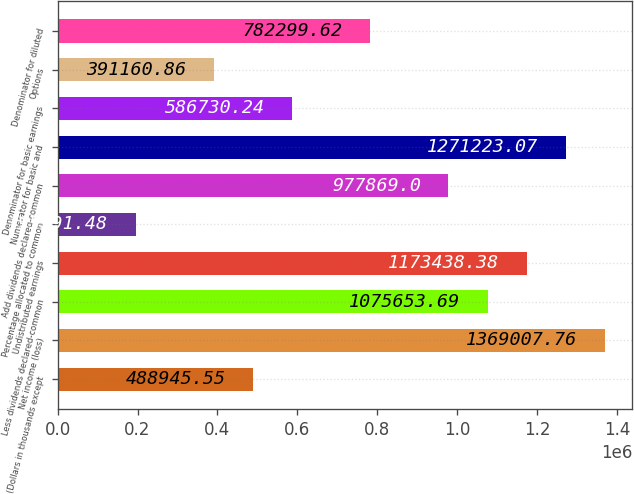Convert chart. <chart><loc_0><loc_0><loc_500><loc_500><bar_chart><fcel>(Dollars in thousands except<fcel>Net income (loss)<fcel>Less dividends declared-common<fcel>Undistributed earnings<fcel>Percentage allocated to common<fcel>Add dividends declared-common<fcel>Numerator for basic and<fcel>Denominator for basic earnings<fcel>Options<fcel>Denominator for diluted<nl><fcel>488946<fcel>1.36901e+06<fcel>1.07565e+06<fcel>1.17344e+06<fcel>195591<fcel>977869<fcel>1.27122e+06<fcel>586730<fcel>391161<fcel>782300<nl></chart> 